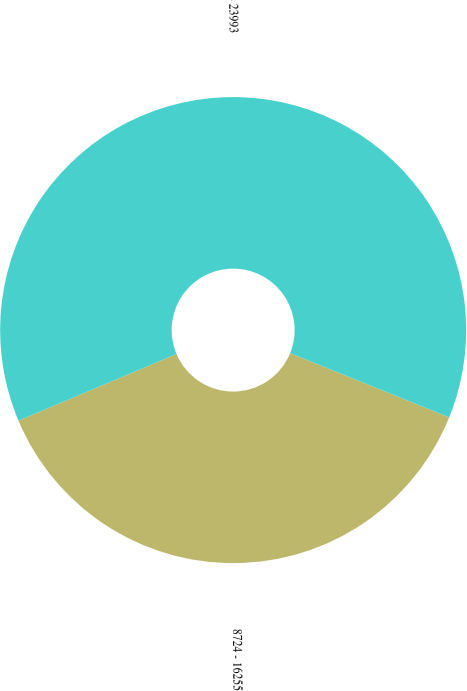Convert chart. <chart><loc_0><loc_0><loc_500><loc_500><pie_chart><fcel>8724 - 16255<fcel>16256 - 23993<nl><fcel>37.54%<fcel>62.46%<nl></chart> 